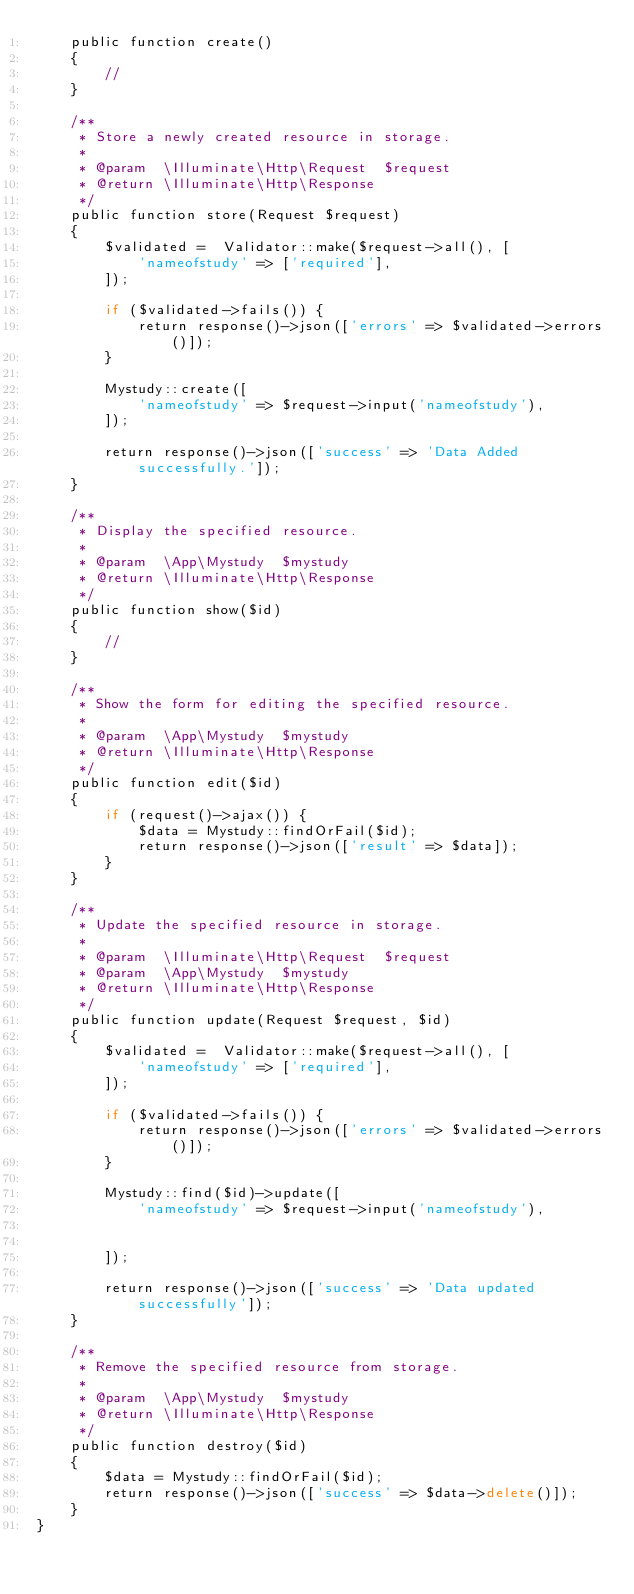Convert code to text. <code><loc_0><loc_0><loc_500><loc_500><_PHP_>    public function create()
    {
        //
    }

    /**
     * Store a newly created resource in storage.
     *
     * @param  \Illuminate\Http\Request  $request
     * @return \Illuminate\Http\Response
     */
    public function store(Request $request)
    {
        $validated =  Validator::make($request->all(), [
            'nameofstudy' => ['required'],
        ]);

        if ($validated->fails()) {
            return response()->json(['errors' => $validated->errors()]);
        }

        Mystudy::create([
            'nameofstudy' => $request->input('nameofstudy'),
        ]);

        return response()->json(['success' => 'Data Added successfully.']);
    }

    /**
     * Display the specified resource.
     *
     * @param  \App\Mystudy  $mystudy
     * @return \Illuminate\Http\Response
     */
    public function show($id)
    {
        //
    }

    /**
     * Show the form for editing the specified resource.
     *
     * @param  \App\Mystudy  $mystudy
     * @return \Illuminate\Http\Response
     */
    public function edit($id)
    {
        if (request()->ajax()) {
            $data = Mystudy::findOrFail($id);
            return response()->json(['result' => $data]);
        }
    }

    /**
     * Update the specified resource in storage.
     *
     * @param  \Illuminate\Http\Request  $request
     * @param  \App\Mystudy  $mystudy
     * @return \Illuminate\Http\Response
     */
    public function update(Request $request, $id)
    {
        $validated =  Validator::make($request->all(), [
            'nameofstudy' => ['required'],
        ]);

        if ($validated->fails()) {
            return response()->json(['errors' => $validated->errors()]);
        }

        Mystudy::find($id)->update([
            'nameofstudy' => $request->input('nameofstudy'),
            
        
        ]);

        return response()->json(['success' => 'Data updated successfully']);
    }

    /**
     * Remove the specified resource from storage.
     *
     * @param  \App\Mystudy  $mystudy
     * @return \Illuminate\Http\Response
     */
    public function destroy($id)
    {
        $data = Mystudy::findOrFail($id);
        return response()->json(['success' => $data->delete()]);
    }
}
</code> 